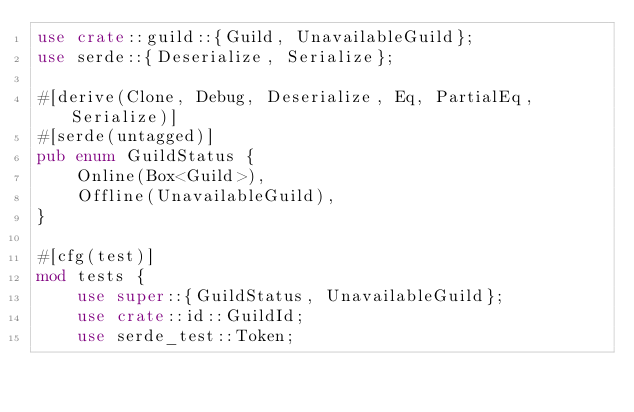Convert code to text. <code><loc_0><loc_0><loc_500><loc_500><_Rust_>use crate::guild::{Guild, UnavailableGuild};
use serde::{Deserialize, Serialize};

#[derive(Clone, Debug, Deserialize, Eq, PartialEq, Serialize)]
#[serde(untagged)]
pub enum GuildStatus {
    Online(Box<Guild>),
    Offline(UnavailableGuild),
}

#[cfg(test)]
mod tests {
    use super::{GuildStatus, UnavailableGuild};
    use crate::id::GuildId;
    use serde_test::Token;
</code> 